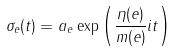<formula> <loc_0><loc_0><loc_500><loc_500>\sigma _ { e } ( t ) = a _ { e } \exp \left ( \frac { \eta ( e ) } { m ( e ) } i t \right )</formula> 